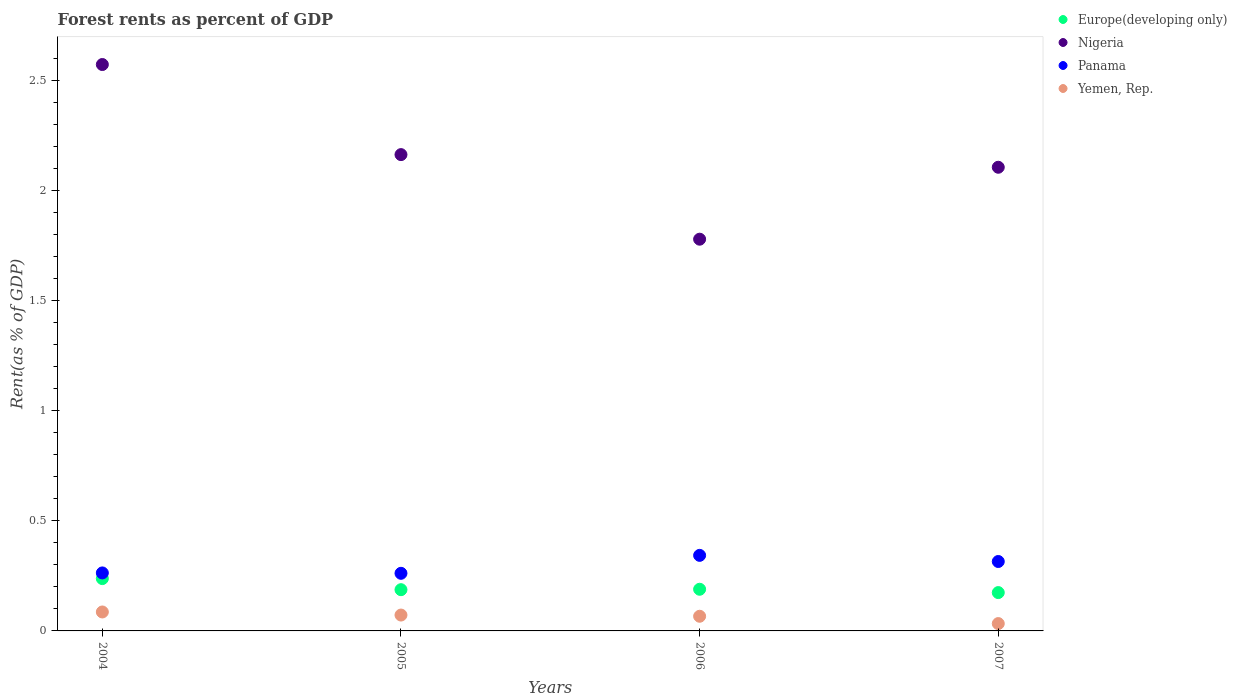Is the number of dotlines equal to the number of legend labels?
Make the answer very short. Yes. What is the forest rent in Yemen, Rep. in 2004?
Your response must be concise. 0.09. Across all years, what is the maximum forest rent in Nigeria?
Your answer should be very brief. 2.57. Across all years, what is the minimum forest rent in Nigeria?
Your answer should be compact. 1.78. In which year was the forest rent in Yemen, Rep. minimum?
Your response must be concise. 2007. What is the total forest rent in Panama in the graph?
Make the answer very short. 1.18. What is the difference between the forest rent in Panama in 2004 and that in 2006?
Your answer should be very brief. -0.08. What is the difference between the forest rent in Yemen, Rep. in 2006 and the forest rent in Panama in 2007?
Make the answer very short. -0.25. What is the average forest rent in Panama per year?
Make the answer very short. 0.3. In the year 2006, what is the difference between the forest rent in Europe(developing only) and forest rent in Nigeria?
Your answer should be compact. -1.59. What is the ratio of the forest rent in Panama in 2005 to that in 2007?
Provide a succinct answer. 0.83. Is the difference between the forest rent in Europe(developing only) in 2004 and 2005 greater than the difference between the forest rent in Nigeria in 2004 and 2005?
Provide a succinct answer. No. What is the difference between the highest and the second highest forest rent in Yemen, Rep.?
Your answer should be compact. 0.01. What is the difference between the highest and the lowest forest rent in Yemen, Rep.?
Give a very brief answer. 0.05. In how many years, is the forest rent in Panama greater than the average forest rent in Panama taken over all years?
Your answer should be very brief. 2. Is the sum of the forest rent in Europe(developing only) in 2005 and 2006 greater than the maximum forest rent in Nigeria across all years?
Make the answer very short. No. Does the forest rent in Europe(developing only) monotonically increase over the years?
Provide a short and direct response. No. Is the forest rent in Europe(developing only) strictly greater than the forest rent in Panama over the years?
Make the answer very short. No. Is the forest rent in Panama strictly less than the forest rent in Nigeria over the years?
Ensure brevity in your answer.  Yes. What is the difference between two consecutive major ticks on the Y-axis?
Provide a succinct answer. 0.5. Are the values on the major ticks of Y-axis written in scientific E-notation?
Your response must be concise. No. Does the graph contain any zero values?
Your answer should be very brief. No. How many legend labels are there?
Offer a very short reply. 4. How are the legend labels stacked?
Your response must be concise. Vertical. What is the title of the graph?
Ensure brevity in your answer.  Forest rents as percent of GDP. Does "Somalia" appear as one of the legend labels in the graph?
Your response must be concise. No. What is the label or title of the Y-axis?
Offer a very short reply. Rent(as % of GDP). What is the Rent(as % of GDP) of Europe(developing only) in 2004?
Provide a succinct answer. 0.24. What is the Rent(as % of GDP) in Nigeria in 2004?
Provide a succinct answer. 2.57. What is the Rent(as % of GDP) of Panama in 2004?
Offer a very short reply. 0.26. What is the Rent(as % of GDP) in Yemen, Rep. in 2004?
Provide a short and direct response. 0.09. What is the Rent(as % of GDP) of Europe(developing only) in 2005?
Your answer should be compact. 0.19. What is the Rent(as % of GDP) of Nigeria in 2005?
Make the answer very short. 2.16. What is the Rent(as % of GDP) in Panama in 2005?
Your response must be concise. 0.26. What is the Rent(as % of GDP) in Yemen, Rep. in 2005?
Your answer should be compact. 0.07. What is the Rent(as % of GDP) in Europe(developing only) in 2006?
Your response must be concise. 0.19. What is the Rent(as % of GDP) in Nigeria in 2006?
Offer a terse response. 1.78. What is the Rent(as % of GDP) in Panama in 2006?
Keep it short and to the point. 0.34. What is the Rent(as % of GDP) of Yemen, Rep. in 2006?
Make the answer very short. 0.07. What is the Rent(as % of GDP) of Europe(developing only) in 2007?
Keep it short and to the point. 0.17. What is the Rent(as % of GDP) in Nigeria in 2007?
Your answer should be very brief. 2.11. What is the Rent(as % of GDP) of Panama in 2007?
Make the answer very short. 0.32. What is the Rent(as % of GDP) of Yemen, Rep. in 2007?
Offer a terse response. 0.03. Across all years, what is the maximum Rent(as % of GDP) of Europe(developing only)?
Give a very brief answer. 0.24. Across all years, what is the maximum Rent(as % of GDP) of Nigeria?
Offer a terse response. 2.57. Across all years, what is the maximum Rent(as % of GDP) of Panama?
Your answer should be very brief. 0.34. Across all years, what is the maximum Rent(as % of GDP) in Yemen, Rep.?
Your answer should be compact. 0.09. Across all years, what is the minimum Rent(as % of GDP) in Europe(developing only)?
Provide a short and direct response. 0.17. Across all years, what is the minimum Rent(as % of GDP) of Nigeria?
Give a very brief answer. 1.78. Across all years, what is the minimum Rent(as % of GDP) in Panama?
Offer a very short reply. 0.26. Across all years, what is the minimum Rent(as % of GDP) of Yemen, Rep.?
Your answer should be very brief. 0.03. What is the total Rent(as % of GDP) in Europe(developing only) in the graph?
Provide a succinct answer. 0.79. What is the total Rent(as % of GDP) of Nigeria in the graph?
Give a very brief answer. 8.62. What is the total Rent(as % of GDP) in Panama in the graph?
Make the answer very short. 1.18. What is the total Rent(as % of GDP) of Yemen, Rep. in the graph?
Offer a terse response. 0.26. What is the difference between the Rent(as % of GDP) of Europe(developing only) in 2004 and that in 2005?
Provide a short and direct response. 0.05. What is the difference between the Rent(as % of GDP) of Nigeria in 2004 and that in 2005?
Provide a short and direct response. 0.41. What is the difference between the Rent(as % of GDP) of Panama in 2004 and that in 2005?
Keep it short and to the point. 0. What is the difference between the Rent(as % of GDP) in Yemen, Rep. in 2004 and that in 2005?
Provide a short and direct response. 0.01. What is the difference between the Rent(as % of GDP) of Europe(developing only) in 2004 and that in 2006?
Your answer should be compact. 0.05. What is the difference between the Rent(as % of GDP) in Nigeria in 2004 and that in 2006?
Provide a short and direct response. 0.79. What is the difference between the Rent(as % of GDP) in Panama in 2004 and that in 2006?
Offer a terse response. -0.08. What is the difference between the Rent(as % of GDP) in Yemen, Rep. in 2004 and that in 2006?
Offer a very short reply. 0.02. What is the difference between the Rent(as % of GDP) in Europe(developing only) in 2004 and that in 2007?
Give a very brief answer. 0.06. What is the difference between the Rent(as % of GDP) of Nigeria in 2004 and that in 2007?
Your answer should be very brief. 0.47. What is the difference between the Rent(as % of GDP) in Panama in 2004 and that in 2007?
Give a very brief answer. -0.05. What is the difference between the Rent(as % of GDP) of Yemen, Rep. in 2004 and that in 2007?
Keep it short and to the point. 0.05. What is the difference between the Rent(as % of GDP) in Europe(developing only) in 2005 and that in 2006?
Keep it short and to the point. -0. What is the difference between the Rent(as % of GDP) of Nigeria in 2005 and that in 2006?
Offer a terse response. 0.38. What is the difference between the Rent(as % of GDP) in Panama in 2005 and that in 2006?
Your response must be concise. -0.08. What is the difference between the Rent(as % of GDP) in Yemen, Rep. in 2005 and that in 2006?
Your answer should be very brief. 0.01. What is the difference between the Rent(as % of GDP) of Europe(developing only) in 2005 and that in 2007?
Make the answer very short. 0.01. What is the difference between the Rent(as % of GDP) of Nigeria in 2005 and that in 2007?
Provide a succinct answer. 0.06. What is the difference between the Rent(as % of GDP) in Panama in 2005 and that in 2007?
Provide a succinct answer. -0.05. What is the difference between the Rent(as % of GDP) in Yemen, Rep. in 2005 and that in 2007?
Give a very brief answer. 0.04. What is the difference between the Rent(as % of GDP) of Europe(developing only) in 2006 and that in 2007?
Offer a terse response. 0.02. What is the difference between the Rent(as % of GDP) of Nigeria in 2006 and that in 2007?
Keep it short and to the point. -0.33. What is the difference between the Rent(as % of GDP) of Panama in 2006 and that in 2007?
Offer a terse response. 0.03. What is the difference between the Rent(as % of GDP) of Yemen, Rep. in 2006 and that in 2007?
Offer a very short reply. 0.03. What is the difference between the Rent(as % of GDP) of Europe(developing only) in 2004 and the Rent(as % of GDP) of Nigeria in 2005?
Ensure brevity in your answer.  -1.93. What is the difference between the Rent(as % of GDP) of Europe(developing only) in 2004 and the Rent(as % of GDP) of Panama in 2005?
Your response must be concise. -0.02. What is the difference between the Rent(as % of GDP) of Europe(developing only) in 2004 and the Rent(as % of GDP) of Yemen, Rep. in 2005?
Provide a succinct answer. 0.17. What is the difference between the Rent(as % of GDP) of Nigeria in 2004 and the Rent(as % of GDP) of Panama in 2005?
Provide a succinct answer. 2.31. What is the difference between the Rent(as % of GDP) of Panama in 2004 and the Rent(as % of GDP) of Yemen, Rep. in 2005?
Your answer should be compact. 0.19. What is the difference between the Rent(as % of GDP) in Europe(developing only) in 2004 and the Rent(as % of GDP) in Nigeria in 2006?
Keep it short and to the point. -1.54. What is the difference between the Rent(as % of GDP) in Europe(developing only) in 2004 and the Rent(as % of GDP) in Panama in 2006?
Provide a succinct answer. -0.11. What is the difference between the Rent(as % of GDP) in Europe(developing only) in 2004 and the Rent(as % of GDP) in Yemen, Rep. in 2006?
Offer a terse response. 0.17. What is the difference between the Rent(as % of GDP) in Nigeria in 2004 and the Rent(as % of GDP) in Panama in 2006?
Your answer should be compact. 2.23. What is the difference between the Rent(as % of GDP) in Nigeria in 2004 and the Rent(as % of GDP) in Yemen, Rep. in 2006?
Your answer should be compact. 2.51. What is the difference between the Rent(as % of GDP) in Panama in 2004 and the Rent(as % of GDP) in Yemen, Rep. in 2006?
Offer a terse response. 0.2. What is the difference between the Rent(as % of GDP) of Europe(developing only) in 2004 and the Rent(as % of GDP) of Nigeria in 2007?
Give a very brief answer. -1.87. What is the difference between the Rent(as % of GDP) in Europe(developing only) in 2004 and the Rent(as % of GDP) in Panama in 2007?
Your response must be concise. -0.08. What is the difference between the Rent(as % of GDP) in Europe(developing only) in 2004 and the Rent(as % of GDP) in Yemen, Rep. in 2007?
Your answer should be compact. 0.2. What is the difference between the Rent(as % of GDP) in Nigeria in 2004 and the Rent(as % of GDP) in Panama in 2007?
Give a very brief answer. 2.26. What is the difference between the Rent(as % of GDP) in Nigeria in 2004 and the Rent(as % of GDP) in Yemen, Rep. in 2007?
Your answer should be compact. 2.54. What is the difference between the Rent(as % of GDP) in Panama in 2004 and the Rent(as % of GDP) in Yemen, Rep. in 2007?
Provide a succinct answer. 0.23. What is the difference between the Rent(as % of GDP) in Europe(developing only) in 2005 and the Rent(as % of GDP) in Nigeria in 2006?
Your response must be concise. -1.59. What is the difference between the Rent(as % of GDP) of Europe(developing only) in 2005 and the Rent(as % of GDP) of Panama in 2006?
Offer a terse response. -0.16. What is the difference between the Rent(as % of GDP) in Europe(developing only) in 2005 and the Rent(as % of GDP) in Yemen, Rep. in 2006?
Provide a succinct answer. 0.12. What is the difference between the Rent(as % of GDP) in Nigeria in 2005 and the Rent(as % of GDP) in Panama in 2006?
Provide a succinct answer. 1.82. What is the difference between the Rent(as % of GDP) in Nigeria in 2005 and the Rent(as % of GDP) in Yemen, Rep. in 2006?
Your response must be concise. 2.1. What is the difference between the Rent(as % of GDP) of Panama in 2005 and the Rent(as % of GDP) of Yemen, Rep. in 2006?
Your response must be concise. 0.2. What is the difference between the Rent(as % of GDP) of Europe(developing only) in 2005 and the Rent(as % of GDP) of Nigeria in 2007?
Give a very brief answer. -1.92. What is the difference between the Rent(as % of GDP) in Europe(developing only) in 2005 and the Rent(as % of GDP) in Panama in 2007?
Make the answer very short. -0.13. What is the difference between the Rent(as % of GDP) in Europe(developing only) in 2005 and the Rent(as % of GDP) in Yemen, Rep. in 2007?
Ensure brevity in your answer.  0.15. What is the difference between the Rent(as % of GDP) in Nigeria in 2005 and the Rent(as % of GDP) in Panama in 2007?
Offer a very short reply. 1.85. What is the difference between the Rent(as % of GDP) of Nigeria in 2005 and the Rent(as % of GDP) of Yemen, Rep. in 2007?
Ensure brevity in your answer.  2.13. What is the difference between the Rent(as % of GDP) in Panama in 2005 and the Rent(as % of GDP) in Yemen, Rep. in 2007?
Make the answer very short. 0.23. What is the difference between the Rent(as % of GDP) of Europe(developing only) in 2006 and the Rent(as % of GDP) of Nigeria in 2007?
Offer a very short reply. -1.92. What is the difference between the Rent(as % of GDP) of Europe(developing only) in 2006 and the Rent(as % of GDP) of Panama in 2007?
Give a very brief answer. -0.13. What is the difference between the Rent(as % of GDP) of Europe(developing only) in 2006 and the Rent(as % of GDP) of Yemen, Rep. in 2007?
Ensure brevity in your answer.  0.16. What is the difference between the Rent(as % of GDP) in Nigeria in 2006 and the Rent(as % of GDP) in Panama in 2007?
Your response must be concise. 1.46. What is the difference between the Rent(as % of GDP) in Nigeria in 2006 and the Rent(as % of GDP) in Yemen, Rep. in 2007?
Offer a very short reply. 1.75. What is the difference between the Rent(as % of GDP) in Panama in 2006 and the Rent(as % of GDP) in Yemen, Rep. in 2007?
Make the answer very short. 0.31. What is the average Rent(as % of GDP) in Europe(developing only) per year?
Offer a terse response. 0.2. What is the average Rent(as % of GDP) of Nigeria per year?
Provide a succinct answer. 2.15. What is the average Rent(as % of GDP) in Panama per year?
Provide a short and direct response. 0.3. What is the average Rent(as % of GDP) of Yemen, Rep. per year?
Provide a short and direct response. 0.06. In the year 2004, what is the difference between the Rent(as % of GDP) of Europe(developing only) and Rent(as % of GDP) of Nigeria?
Give a very brief answer. -2.33. In the year 2004, what is the difference between the Rent(as % of GDP) in Europe(developing only) and Rent(as % of GDP) in Panama?
Your response must be concise. -0.03. In the year 2004, what is the difference between the Rent(as % of GDP) of Europe(developing only) and Rent(as % of GDP) of Yemen, Rep.?
Offer a terse response. 0.15. In the year 2004, what is the difference between the Rent(as % of GDP) of Nigeria and Rent(as % of GDP) of Panama?
Offer a very short reply. 2.31. In the year 2004, what is the difference between the Rent(as % of GDP) in Nigeria and Rent(as % of GDP) in Yemen, Rep.?
Offer a very short reply. 2.49. In the year 2004, what is the difference between the Rent(as % of GDP) of Panama and Rent(as % of GDP) of Yemen, Rep.?
Give a very brief answer. 0.18. In the year 2005, what is the difference between the Rent(as % of GDP) of Europe(developing only) and Rent(as % of GDP) of Nigeria?
Offer a very short reply. -1.98. In the year 2005, what is the difference between the Rent(as % of GDP) in Europe(developing only) and Rent(as % of GDP) in Panama?
Provide a succinct answer. -0.07. In the year 2005, what is the difference between the Rent(as % of GDP) in Europe(developing only) and Rent(as % of GDP) in Yemen, Rep.?
Make the answer very short. 0.12. In the year 2005, what is the difference between the Rent(as % of GDP) of Nigeria and Rent(as % of GDP) of Panama?
Your answer should be compact. 1.9. In the year 2005, what is the difference between the Rent(as % of GDP) of Nigeria and Rent(as % of GDP) of Yemen, Rep.?
Make the answer very short. 2.09. In the year 2005, what is the difference between the Rent(as % of GDP) in Panama and Rent(as % of GDP) in Yemen, Rep.?
Your answer should be very brief. 0.19. In the year 2006, what is the difference between the Rent(as % of GDP) of Europe(developing only) and Rent(as % of GDP) of Nigeria?
Your answer should be compact. -1.59. In the year 2006, what is the difference between the Rent(as % of GDP) in Europe(developing only) and Rent(as % of GDP) in Panama?
Keep it short and to the point. -0.15. In the year 2006, what is the difference between the Rent(as % of GDP) in Europe(developing only) and Rent(as % of GDP) in Yemen, Rep.?
Your answer should be very brief. 0.12. In the year 2006, what is the difference between the Rent(as % of GDP) of Nigeria and Rent(as % of GDP) of Panama?
Your answer should be compact. 1.44. In the year 2006, what is the difference between the Rent(as % of GDP) of Nigeria and Rent(as % of GDP) of Yemen, Rep.?
Give a very brief answer. 1.71. In the year 2006, what is the difference between the Rent(as % of GDP) of Panama and Rent(as % of GDP) of Yemen, Rep.?
Give a very brief answer. 0.28. In the year 2007, what is the difference between the Rent(as % of GDP) of Europe(developing only) and Rent(as % of GDP) of Nigeria?
Make the answer very short. -1.93. In the year 2007, what is the difference between the Rent(as % of GDP) of Europe(developing only) and Rent(as % of GDP) of Panama?
Ensure brevity in your answer.  -0.14. In the year 2007, what is the difference between the Rent(as % of GDP) of Europe(developing only) and Rent(as % of GDP) of Yemen, Rep.?
Provide a succinct answer. 0.14. In the year 2007, what is the difference between the Rent(as % of GDP) in Nigeria and Rent(as % of GDP) in Panama?
Keep it short and to the point. 1.79. In the year 2007, what is the difference between the Rent(as % of GDP) of Nigeria and Rent(as % of GDP) of Yemen, Rep.?
Ensure brevity in your answer.  2.07. In the year 2007, what is the difference between the Rent(as % of GDP) in Panama and Rent(as % of GDP) in Yemen, Rep.?
Your response must be concise. 0.28. What is the ratio of the Rent(as % of GDP) in Europe(developing only) in 2004 to that in 2005?
Your answer should be very brief. 1.27. What is the ratio of the Rent(as % of GDP) of Nigeria in 2004 to that in 2005?
Your answer should be compact. 1.19. What is the ratio of the Rent(as % of GDP) in Yemen, Rep. in 2004 to that in 2005?
Your answer should be compact. 1.19. What is the ratio of the Rent(as % of GDP) in Europe(developing only) in 2004 to that in 2006?
Make the answer very short. 1.26. What is the ratio of the Rent(as % of GDP) in Nigeria in 2004 to that in 2006?
Your answer should be compact. 1.45. What is the ratio of the Rent(as % of GDP) of Panama in 2004 to that in 2006?
Offer a very short reply. 0.77. What is the ratio of the Rent(as % of GDP) of Yemen, Rep. in 2004 to that in 2006?
Your answer should be very brief. 1.29. What is the ratio of the Rent(as % of GDP) of Europe(developing only) in 2004 to that in 2007?
Offer a terse response. 1.36. What is the ratio of the Rent(as % of GDP) of Nigeria in 2004 to that in 2007?
Your response must be concise. 1.22. What is the ratio of the Rent(as % of GDP) of Panama in 2004 to that in 2007?
Provide a short and direct response. 0.84. What is the ratio of the Rent(as % of GDP) of Yemen, Rep. in 2004 to that in 2007?
Offer a terse response. 2.58. What is the ratio of the Rent(as % of GDP) in Europe(developing only) in 2005 to that in 2006?
Give a very brief answer. 0.99. What is the ratio of the Rent(as % of GDP) of Nigeria in 2005 to that in 2006?
Offer a very short reply. 1.22. What is the ratio of the Rent(as % of GDP) of Panama in 2005 to that in 2006?
Your answer should be compact. 0.76. What is the ratio of the Rent(as % of GDP) of Yemen, Rep. in 2005 to that in 2006?
Your answer should be very brief. 1.08. What is the ratio of the Rent(as % of GDP) of Europe(developing only) in 2005 to that in 2007?
Offer a terse response. 1.08. What is the ratio of the Rent(as % of GDP) of Nigeria in 2005 to that in 2007?
Ensure brevity in your answer.  1.03. What is the ratio of the Rent(as % of GDP) in Panama in 2005 to that in 2007?
Make the answer very short. 0.83. What is the ratio of the Rent(as % of GDP) of Yemen, Rep. in 2005 to that in 2007?
Your answer should be very brief. 2.16. What is the ratio of the Rent(as % of GDP) in Europe(developing only) in 2006 to that in 2007?
Offer a very short reply. 1.09. What is the ratio of the Rent(as % of GDP) of Nigeria in 2006 to that in 2007?
Keep it short and to the point. 0.84. What is the ratio of the Rent(as % of GDP) in Panama in 2006 to that in 2007?
Your response must be concise. 1.09. What is the ratio of the Rent(as % of GDP) of Yemen, Rep. in 2006 to that in 2007?
Provide a short and direct response. 2. What is the difference between the highest and the second highest Rent(as % of GDP) of Europe(developing only)?
Provide a short and direct response. 0.05. What is the difference between the highest and the second highest Rent(as % of GDP) of Nigeria?
Keep it short and to the point. 0.41. What is the difference between the highest and the second highest Rent(as % of GDP) of Panama?
Offer a terse response. 0.03. What is the difference between the highest and the second highest Rent(as % of GDP) in Yemen, Rep.?
Give a very brief answer. 0.01. What is the difference between the highest and the lowest Rent(as % of GDP) in Europe(developing only)?
Ensure brevity in your answer.  0.06. What is the difference between the highest and the lowest Rent(as % of GDP) in Nigeria?
Ensure brevity in your answer.  0.79. What is the difference between the highest and the lowest Rent(as % of GDP) of Panama?
Provide a short and direct response. 0.08. What is the difference between the highest and the lowest Rent(as % of GDP) of Yemen, Rep.?
Your answer should be compact. 0.05. 